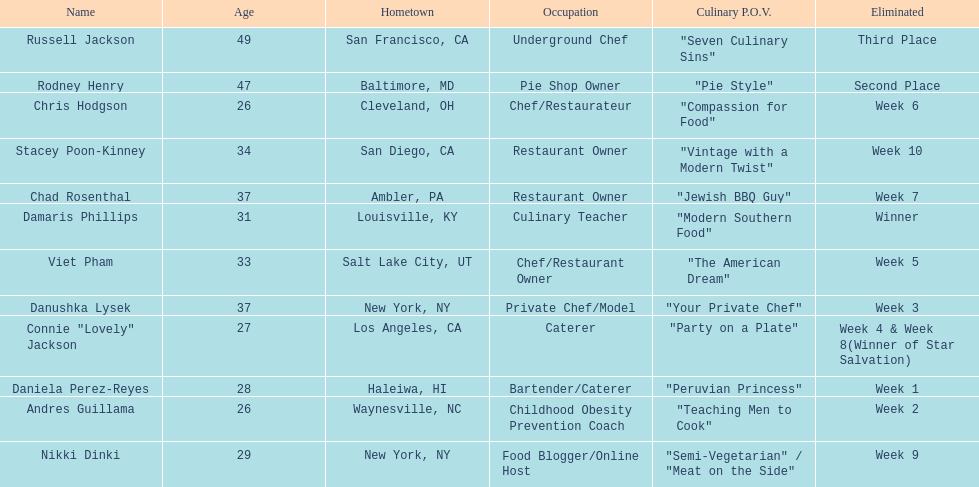How many competitors were under the age of 30? 5. Could you parse the entire table as a dict? {'header': ['Name', 'Age', 'Hometown', 'Occupation', 'Culinary P.O.V.', 'Eliminated'], 'rows': [['Russell Jackson', '49', 'San Francisco, CA', 'Underground Chef', '"Seven Culinary Sins"', 'Third Place'], ['Rodney Henry', '47', 'Baltimore, MD', 'Pie Shop Owner', '"Pie Style"', 'Second Place'], ['Chris Hodgson', '26', 'Cleveland, OH', 'Chef/Restaurateur', '"Compassion for Food"', 'Week 6'], ['Stacey Poon-Kinney', '34', 'San Diego, CA', 'Restaurant Owner', '"Vintage with a Modern Twist"', 'Week 10'], ['Chad Rosenthal', '37', 'Ambler, PA', 'Restaurant Owner', '"Jewish BBQ Guy"', 'Week 7'], ['Damaris Phillips', '31', 'Louisville, KY', 'Culinary Teacher', '"Modern Southern Food"', 'Winner'], ['Viet Pham', '33', 'Salt Lake City, UT', 'Chef/Restaurant Owner', '"The American Dream"', 'Week 5'], ['Danushka Lysek', '37', 'New York, NY', 'Private Chef/Model', '"Your Private Chef"', 'Week 3'], ['Connie "Lovely" Jackson', '27', 'Los Angeles, CA', 'Caterer', '"Party on a Plate"', 'Week 4 & Week 8(Winner of Star Salvation)'], ['Daniela Perez-Reyes', '28', 'Haleiwa, HI', 'Bartender/Caterer', '"Peruvian Princess"', 'Week 1'], ['Andres Guillama', '26', 'Waynesville, NC', 'Childhood Obesity Prevention Coach', '"Teaching Men to Cook"', 'Week 2'], ['Nikki Dinki', '29', 'New York, NY', 'Food Blogger/Online Host', '"Semi-Vegetarian" / "Meat on the Side"', 'Week 9']]} 